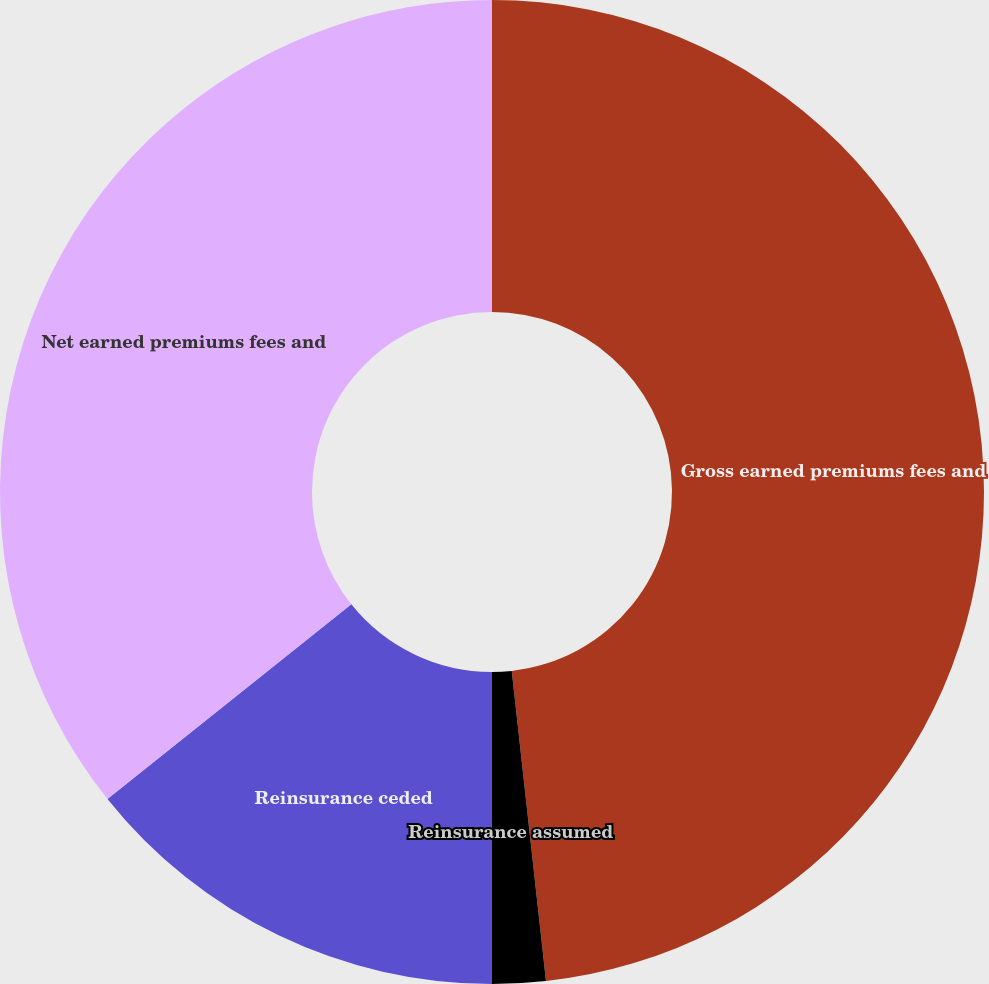<chart> <loc_0><loc_0><loc_500><loc_500><pie_chart><fcel>Gross earned premiums fees and<fcel>Reinsurance assumed<fcel>Reinsurance ceded<fcel>Net earned premiums fees and<nl><fcel>48.25%<fcel>1.75%<fcel>14.28%<fcel>35.72%<nl></chart> 